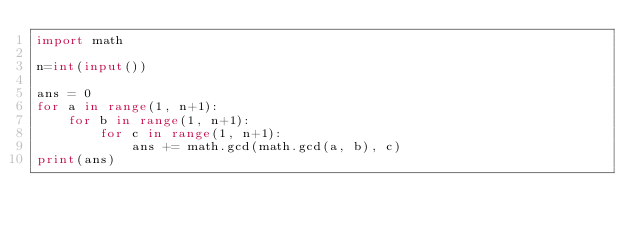Convert code to text. <code><loc_0><loc_0><loc_500><loc_500><_Python_>import math

n=int(input())

ans = 0
for a in range(1, n+1):
    for b in range(1, n+1):
        for c in range(1, n+1):
            ans += math.gcd(math.gcd(a, b), c)
print(ans)</code> 